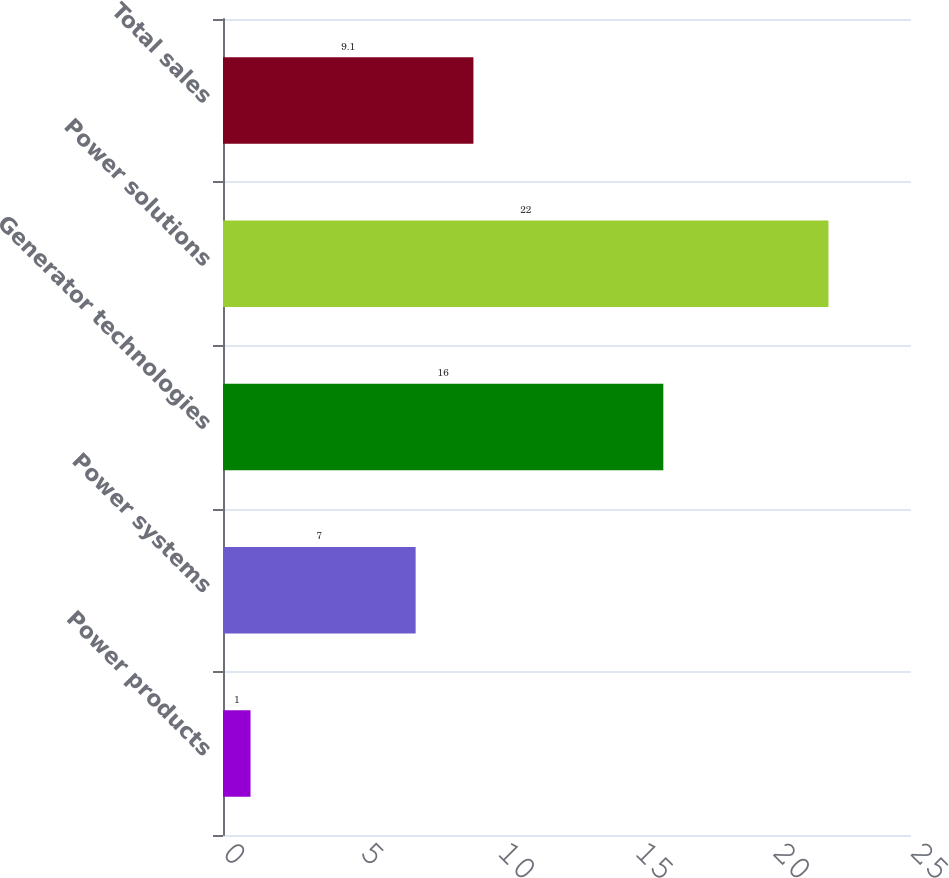<chart> <loc_0><loc_0><loc_500><loc_500><bar_chart><fcel>Power products<fcel>Power systems<fcel>Generator technologies<fcel>Power solutions<fcel>Total sales<nl><fcel>1<fcel>7<fcel>16<fcel>22<fcel>9.1<nl></chart> 